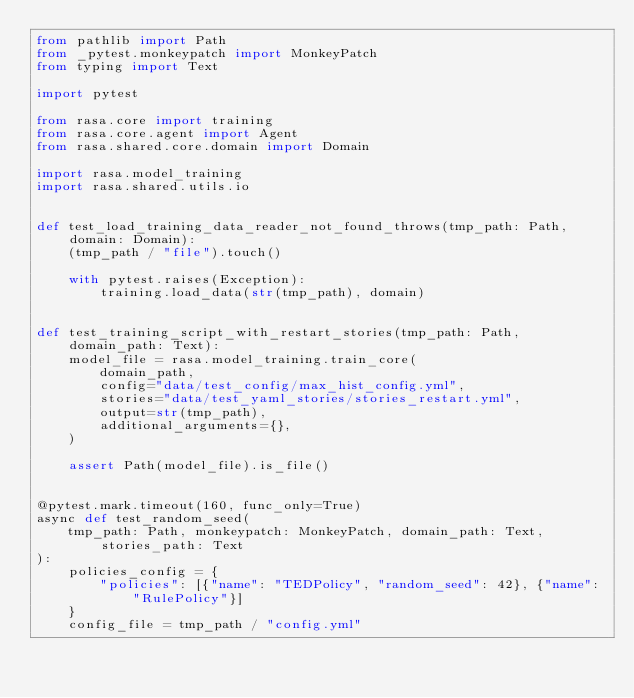<code> <loc_0><loc_0><loc_500><loc_500><_Python_>from pathlib import Path
from _pytest.monkeypatch import MonkeyPatch
from typing import Text

import pytest

from rasa.core import training
from rasa.core.agent import Agent
from rasa.shared.core.domain import Domain

import rasa.model_training
import rasa.shared.utils.io


def test_load_training_data_reader_not_found_throws(tmp_path: Path, domain: Domain):
    (tmp_path / "file").touch()

    with pytest.raises(Exception):
        training.load_data(str(tmp_path), domain)


def test_training_script_with_restart_stories(tmp_path: Path, domain_path: Text):
    model_file = rasa.model_training.train_core(
        domain_path,
        config="data/test_config/max_hist_config.yml",
        stories="data/test_yaml_stories/stories_restart.yml",
        output=str(tmp_path),
        additional_arguments={},
    )

    assert Path(model_file).is_file()


@pytest.mark.timeout(160, func_only=True)
async def test_random_seed(
    tmp_path: Path, monkeypatch: MonkeyPatch, domain_path: Text, stories_path: Text
):
    policies_config = {
        "policies": [{"name": "TEDPolicy", "random_seed": 42}, {"name": "RulePolicy"}]
    }
    config_file = tmp_path / "config.yml"</code> 